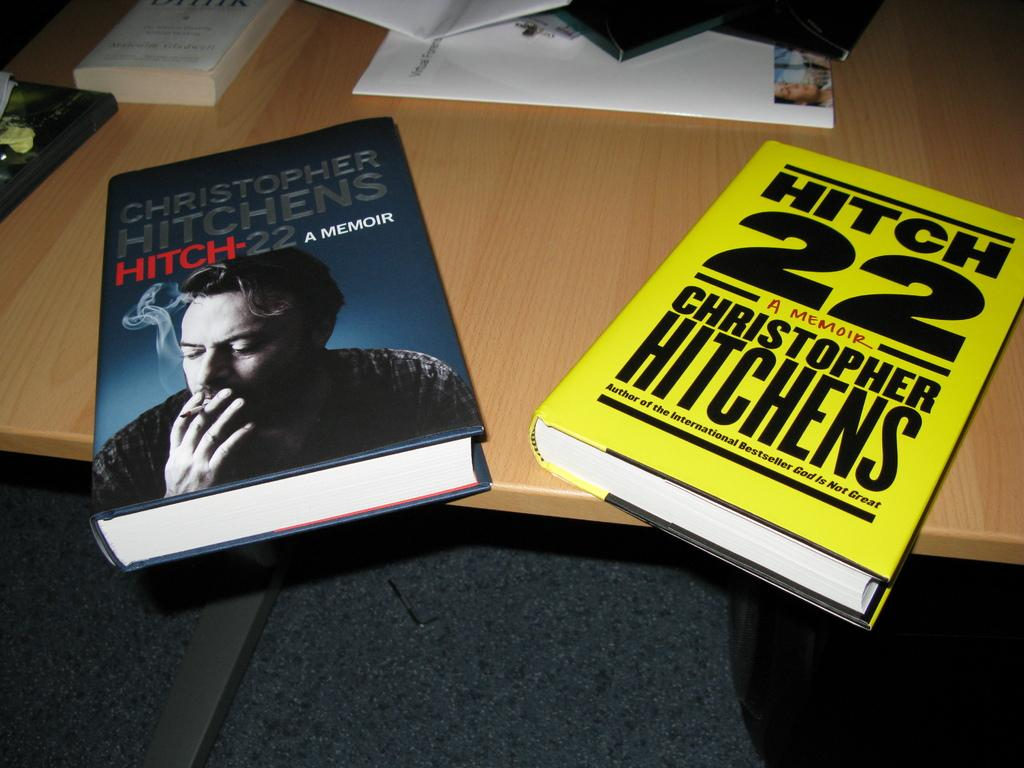Provide a one-sentence caption for the provided image. Two books from the author Christopher Hitchens are on the table. 